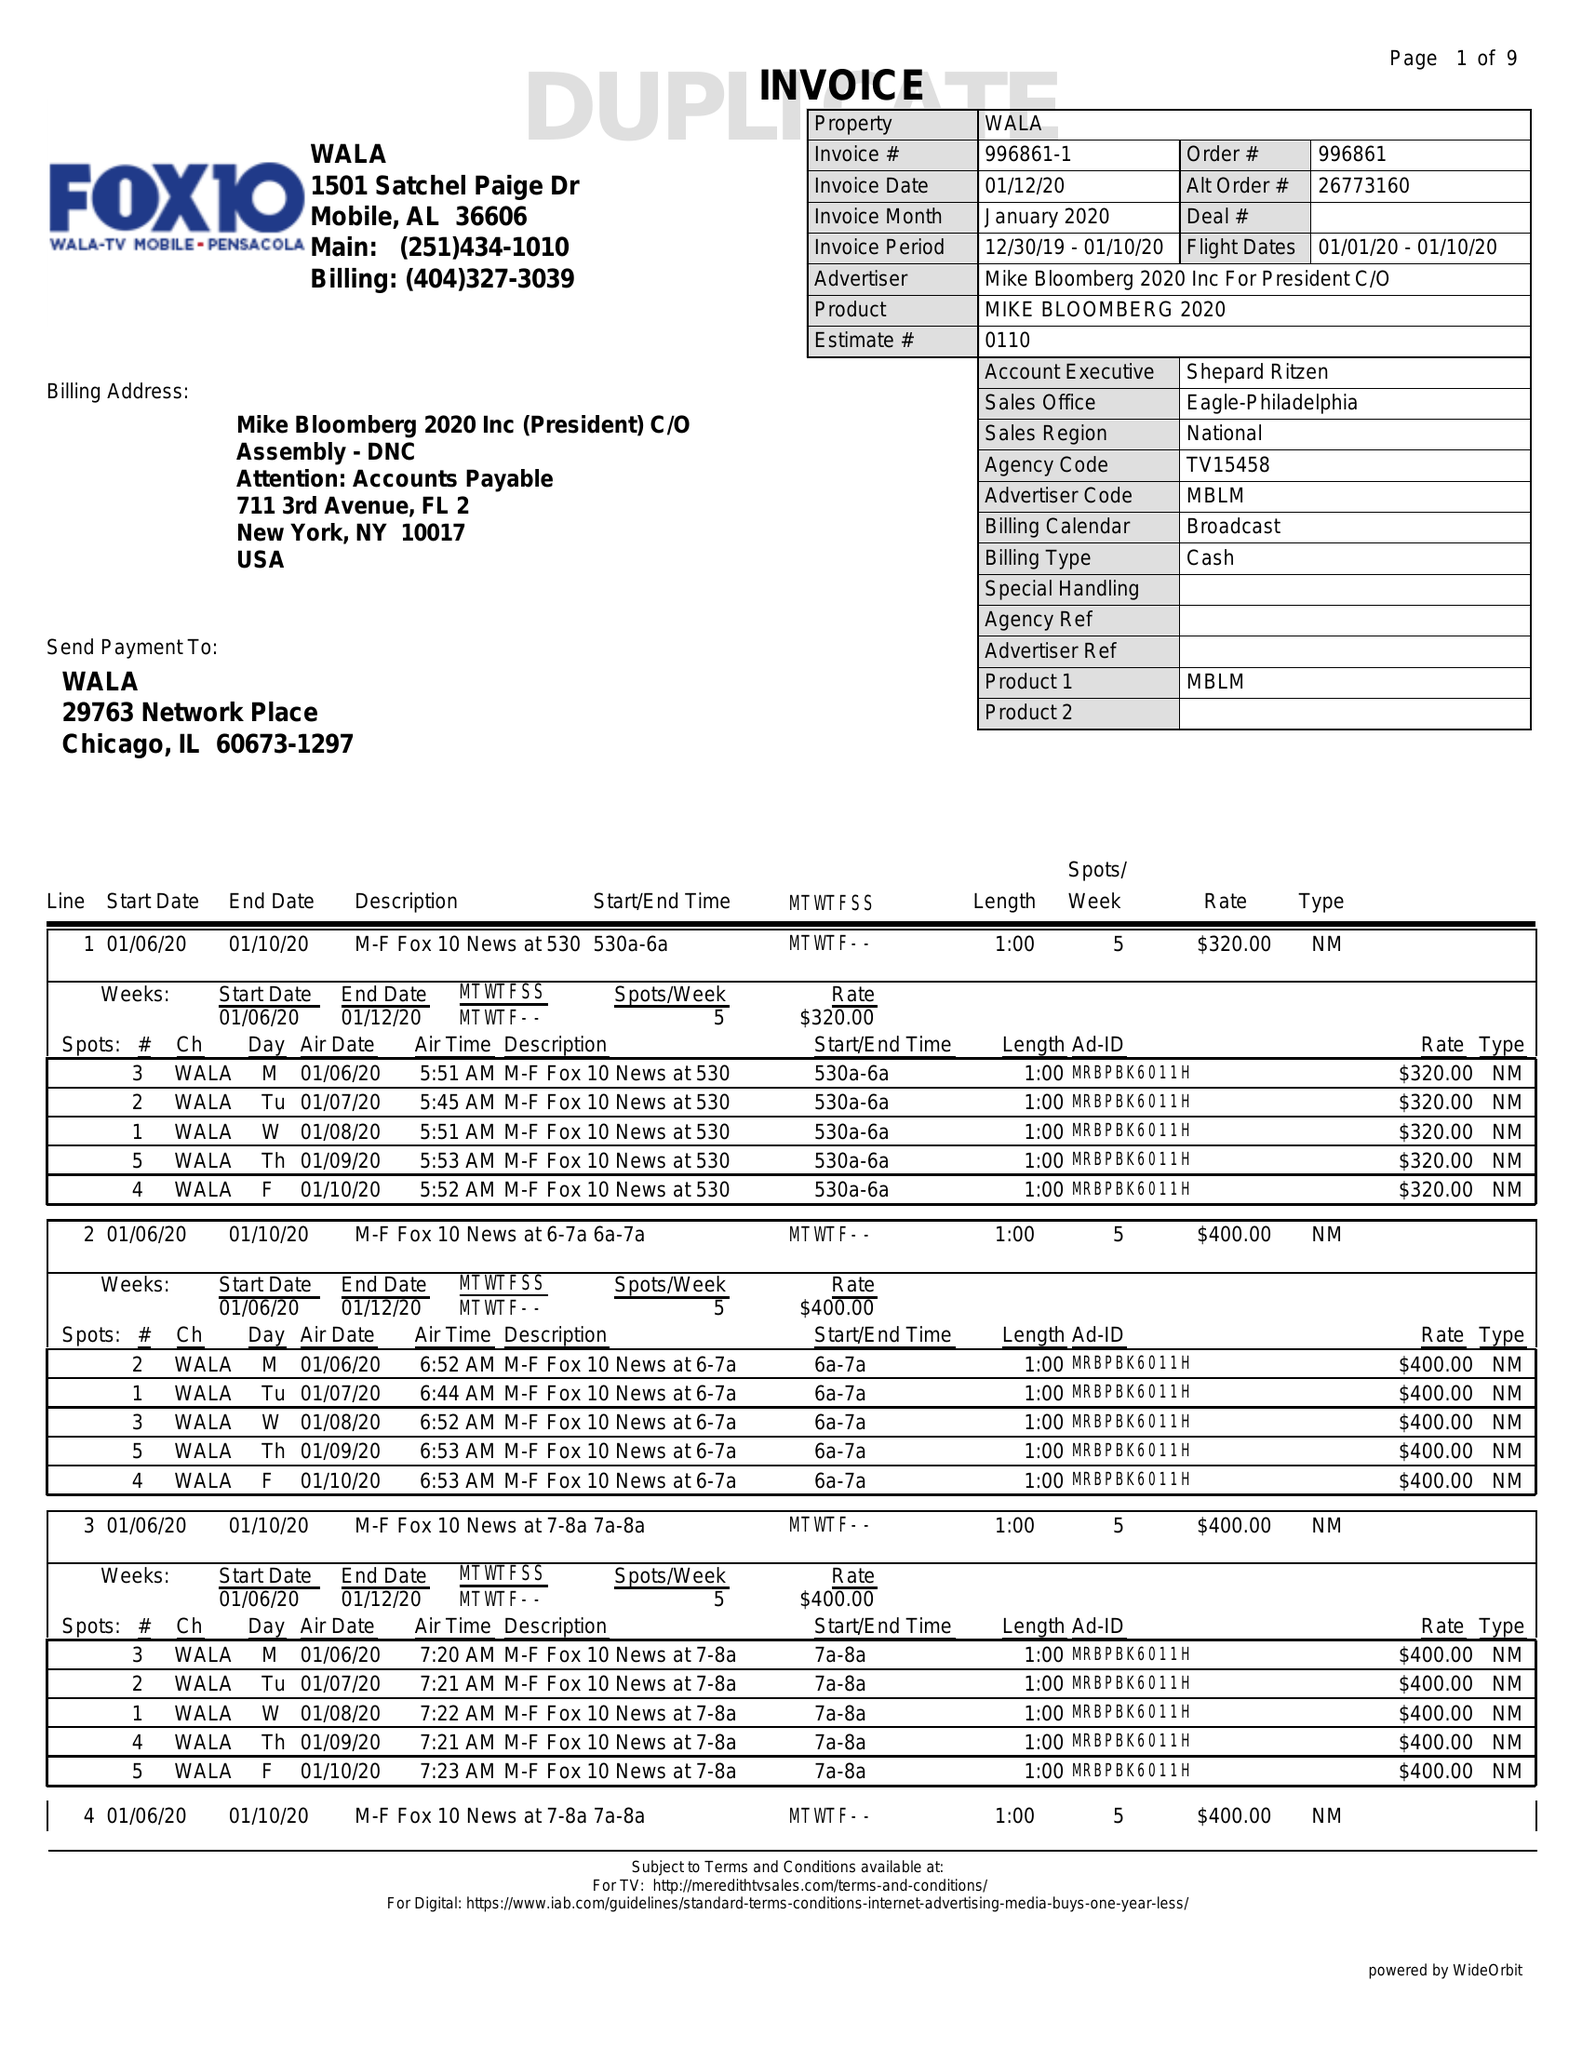What is the value for the flight_from?
Answer the question using a single word or phrase. 01/01/20 